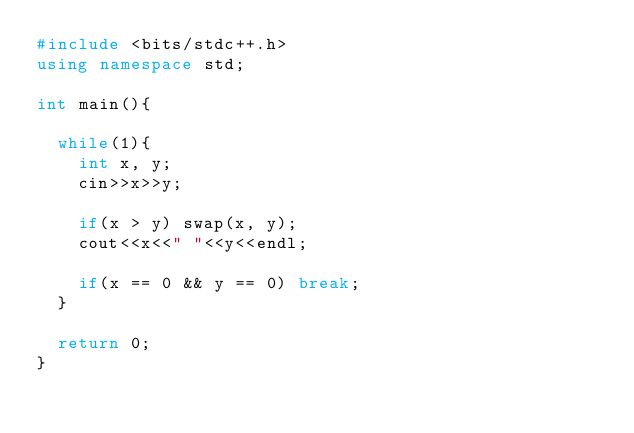<code> <loc_0><loc_0><loc_500><loc_500><_C++_>#include <bits/stdc++.h>
using namespace std;

int main(){

  while(1){
    int x, y;
    cin>>x>>y;

    if(x > y) swap(x, y);
    cout<<x<<" "<<y<<endl;

    if(x == 0 && y == 0) break;
  }

  return 0;
}

</code> 